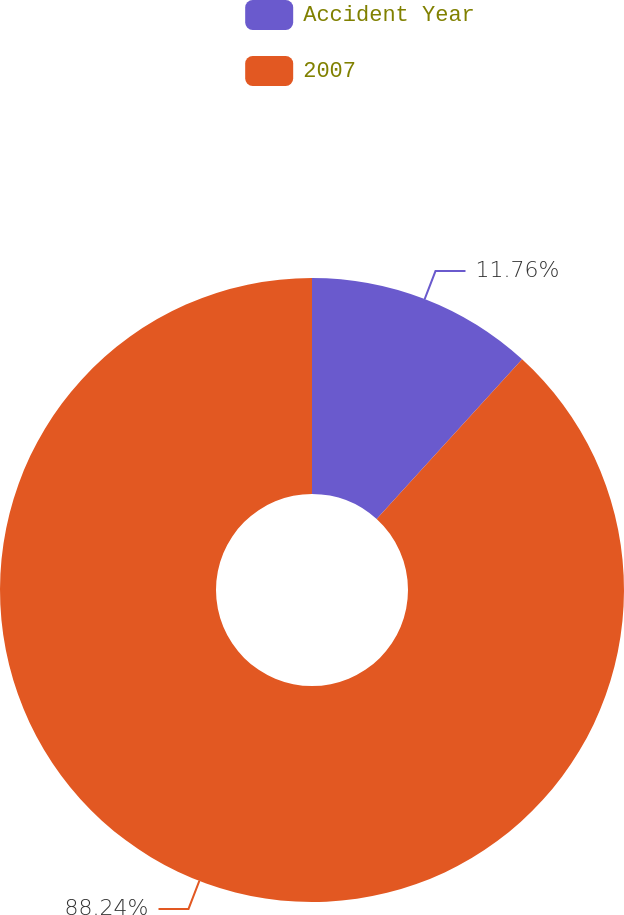Convert chart to OTSL. <chart><loc_0><loc_0><loc_500><loc_500><pie_chart><fcel>Accident Year<fcel>2007<nl><fcel>11.76%<fcel>88.24%<nl></chart> 